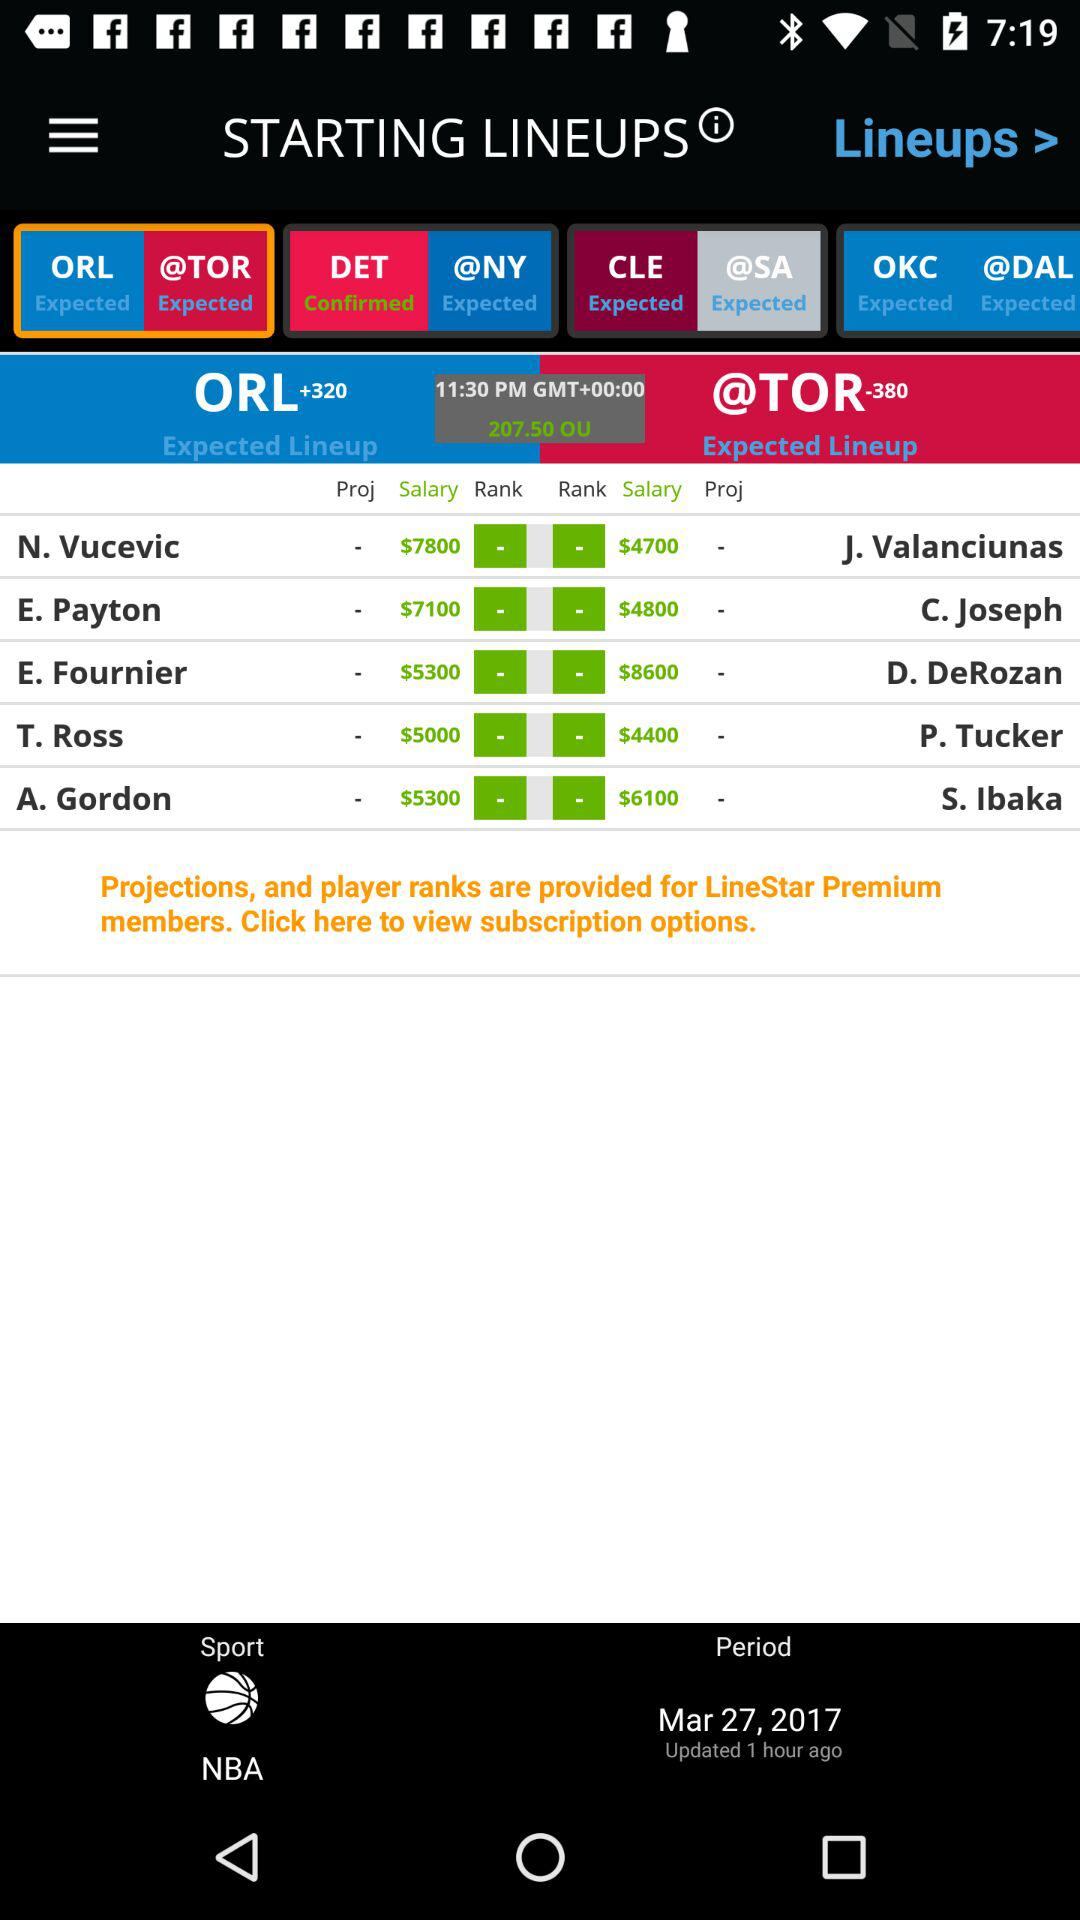What is the salary of E. Payton? The salary of E. Payton is $7100. 